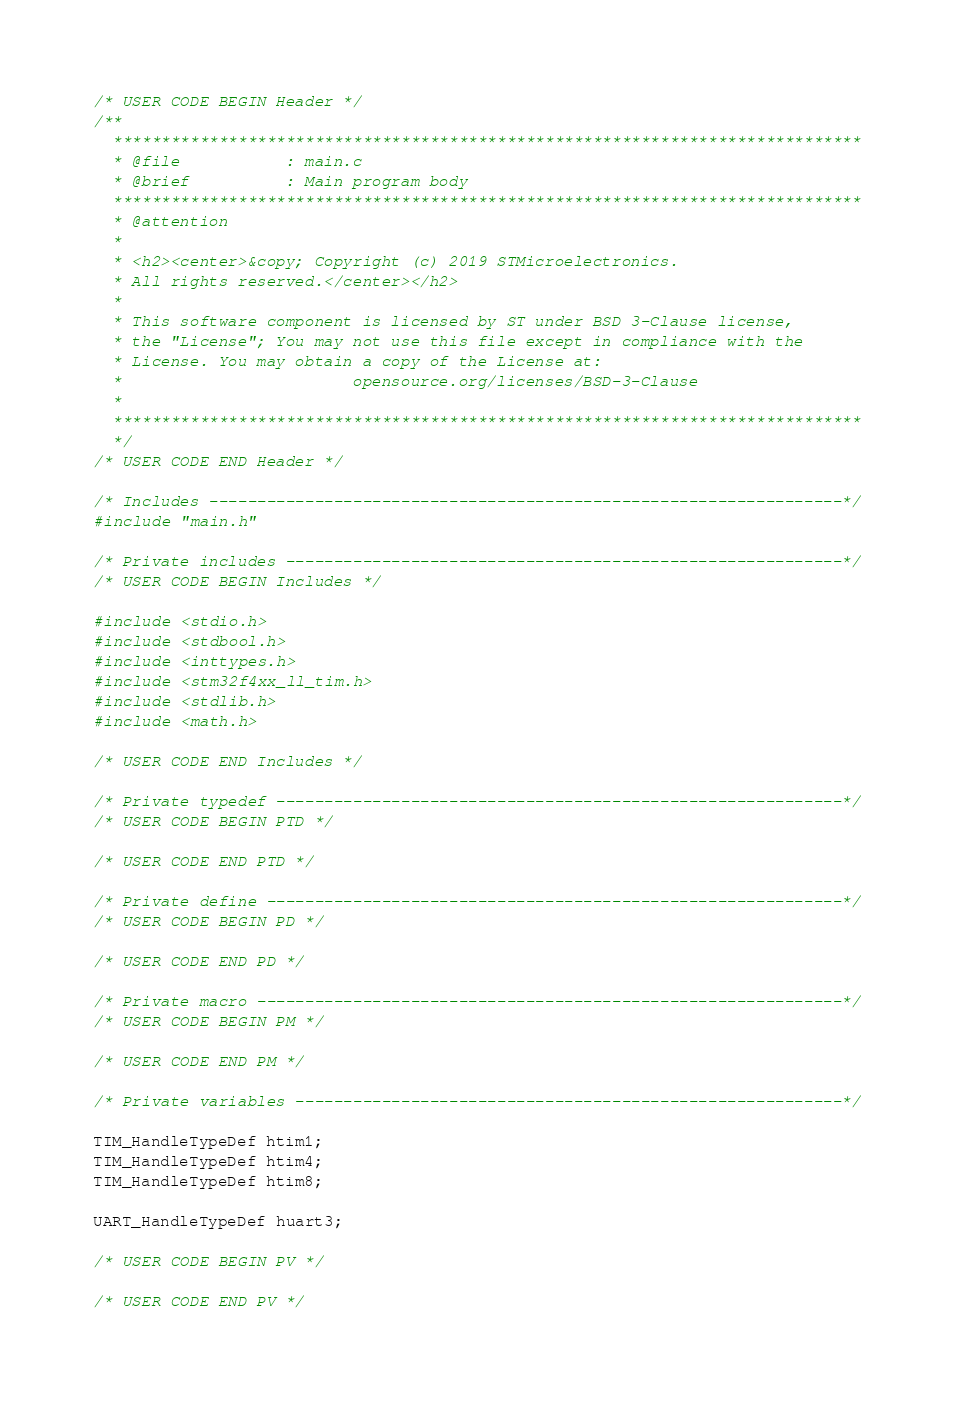Convert code to text. <code><loc_0><loc_0><loc_500><loc_500><_C_>/* USER CODE BEGIN Header */
/**
  ******************************************************************************
  * @file           : main.c
  * @brief          : Main program body
  ******************************************************************************
  * @attention
  *
  * <h2><center>&copy; Copyright (c) 2019 STMicroelectronics.
  * All rights reserved.</center></h2>
  *
  * This software component is licensed by ST under BSD 3-Clause license,
  * the "License"; You may not use this file except in compliance with the
  * License. You may obtain a copy of the License at:
  *                        opensource.org/licenses/BSD-3-Clause
  *
  ******************************************************************************
  */
/* USER CODE END Header */

/* Includes ------------------------------------------------------------------*/
#include "main.h"

/* Private includes ----------------------------------------------------------*/
/* USER CODE BEGIN Includes */

#include <stdio.h>
#include <stdbool.h>
#include <inttypes.h>
#include <stm32f4xx_ll_tim.h>
#include <stdlib.h>
#include <math.h>

/* USER CODE END Includes */

/* Private typedef -----------------------------------------------------------*/
/* USER CODE BEGIN PTD */

/* USER CODE END PTD */

/* Private define ------------------------------------------------------------*/
/* USER CODE BEGIN PD */

/* USER CODE END PD */

/* Private macro -------------------------------------------------------------*/
/* USER CODE BEGIN PM */

/* USER CODE END PM */

/* Private variables ---------------------------------------------------------*/

TIM_HandleTypeDef htim1;
TIM_HandleTypeDef htim4;
TIM_HandleTypeDef htim8;

UART_HandleTypeDef huart3;

/* USER CODE BEGIN PV */

/* USER CODE END PV */
</code> 